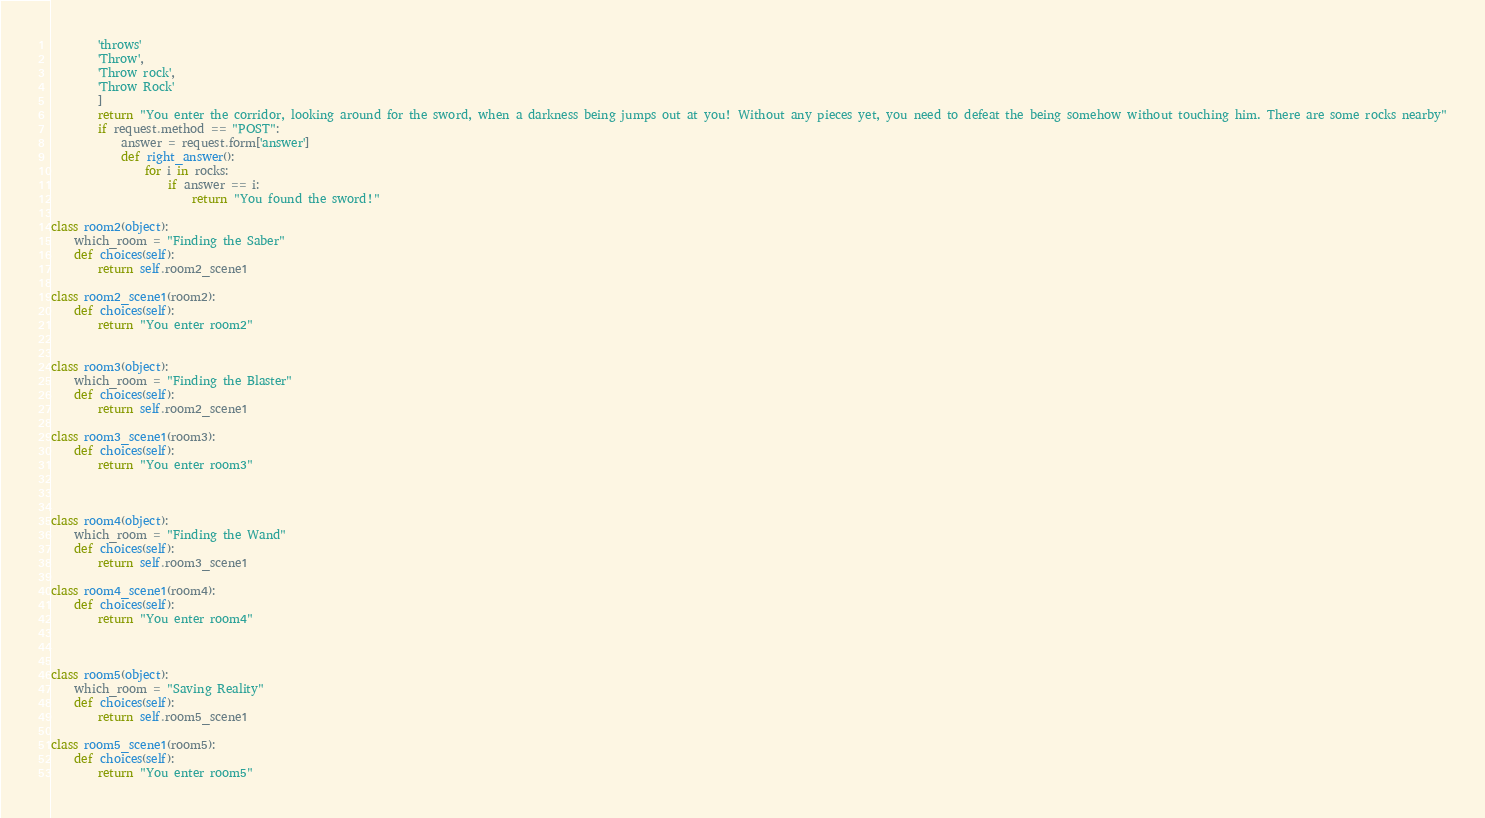Convert code to text. <code><loc_0><loc_0><loc_500><loc_500><_Python_>        'throws'
        'Throw',
        'Throw rock',
        'Throw Rock'
        ]
        return "You enter the corridor, looking around for the sword, when a darkness being jumps out at you! Without any pieces yet, you need to defeat the being somehow without touching him. There are some rocks nearby"
        if request.method == "POST":
            answer = request.form['answer']
            def right_answer():
                for i in rocks:
                    if answer == i:
                        return "You found the sword!"

class room2(object):
    which_room = "Finding the Saber"
    def choices(self):
        return self.room2_scene1

class room2_scene1(room2):
    def choices(self):
        return "You enter room2"


class room3(object):
    which_room = "Finding the Blaster"
    def choices(self):
        return self.room2_scene1

class room3_scene1(room3):
    def choices(self):
        return "You enter room3"



class room4(object):
    which_room = "Finding the Wand"
    def choices(self):
        return self.room3_scene1

class room4_scene1(room4):
    def choices(self):
        return "You enter room4"



class room5(object):
    which_room = "Saving Reality"
    def choices(self):
        return self.room5_scene1

class room5_scene1(room5):
    def choices(self):
        return "You enter room5"
</code> 